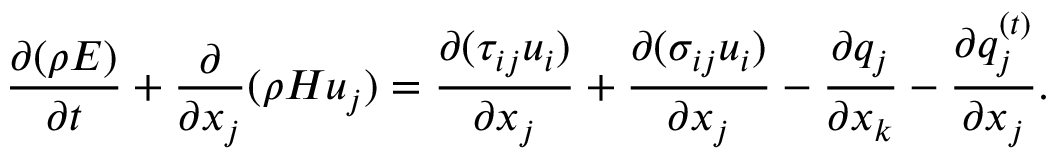<formula> <loc_0><loc_0><loc_500><loc_500>\frac { \partial ( \rho E ) } { \partial t } + \frac { \partial } { { \partial { x _ { j } } } } ( \rho H { u _ { j } } ) = \frac { { \partial ( { \tau _ { i j } } { u _ { i } } ) } } { { \partial { x _ { j } } } } + \frac { { \partial ( { \sigma _ { i j } } { u _ { i } } ) } } { { \partial { x _ { j } } } } - \frac { { \partial { q _ { j } } } } { { \partial { x _ { k } } } } - \frac { { \partial q _ { j } ^ { \left ( t \right ) } } } { { \partial { x _ { j } } } } .</formula> 